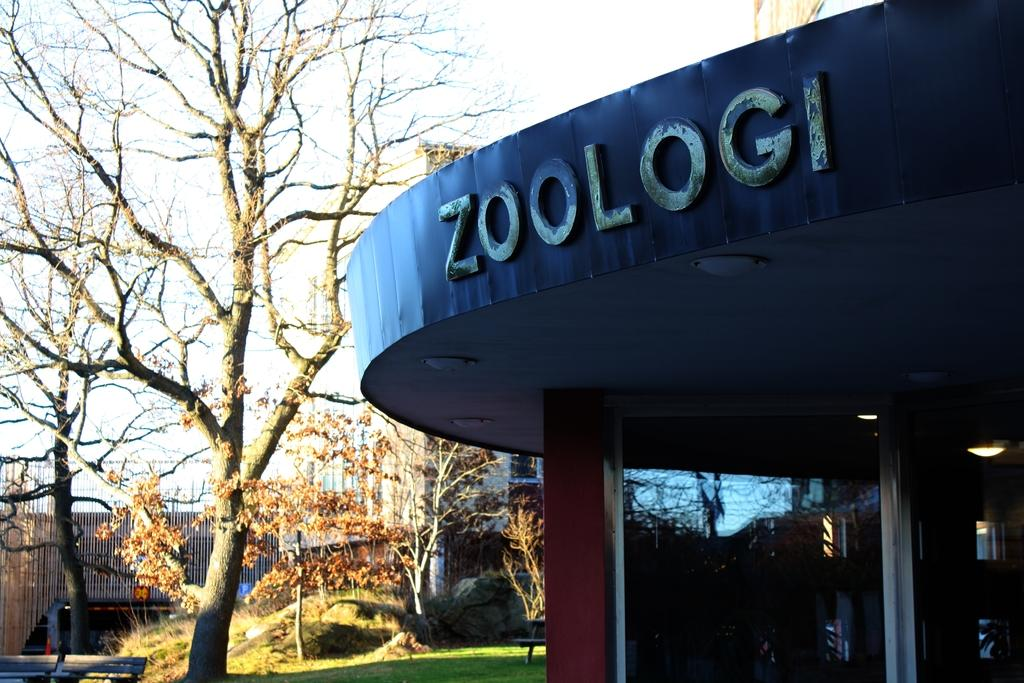What type of structure is present in the image? There is a building in the image. What natural elements can be seen in the image? There are trees and plants in the image. What type of seating is available in the image? There are benches in the image. What type of geological feature is present in the image? There are rocks in the image. What is visible in the background of the image? The sky is visible in the background of the image. What type of stocking is the governor wearing in the image? There is no governor or stocking present in the image. What type of town is depicted in the image? The image does not depict a town; it features a building, trees, plants, benches, rocks, and the sky. 